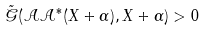<formula> <loc_0><loc_0><loc_500><loc_500>\tilde { \mathcal { G } } ( \mathcal { A } \mathcal { A } ^ { * } ( X + \alpha ) , X + \alpha ) > 0</formula> 